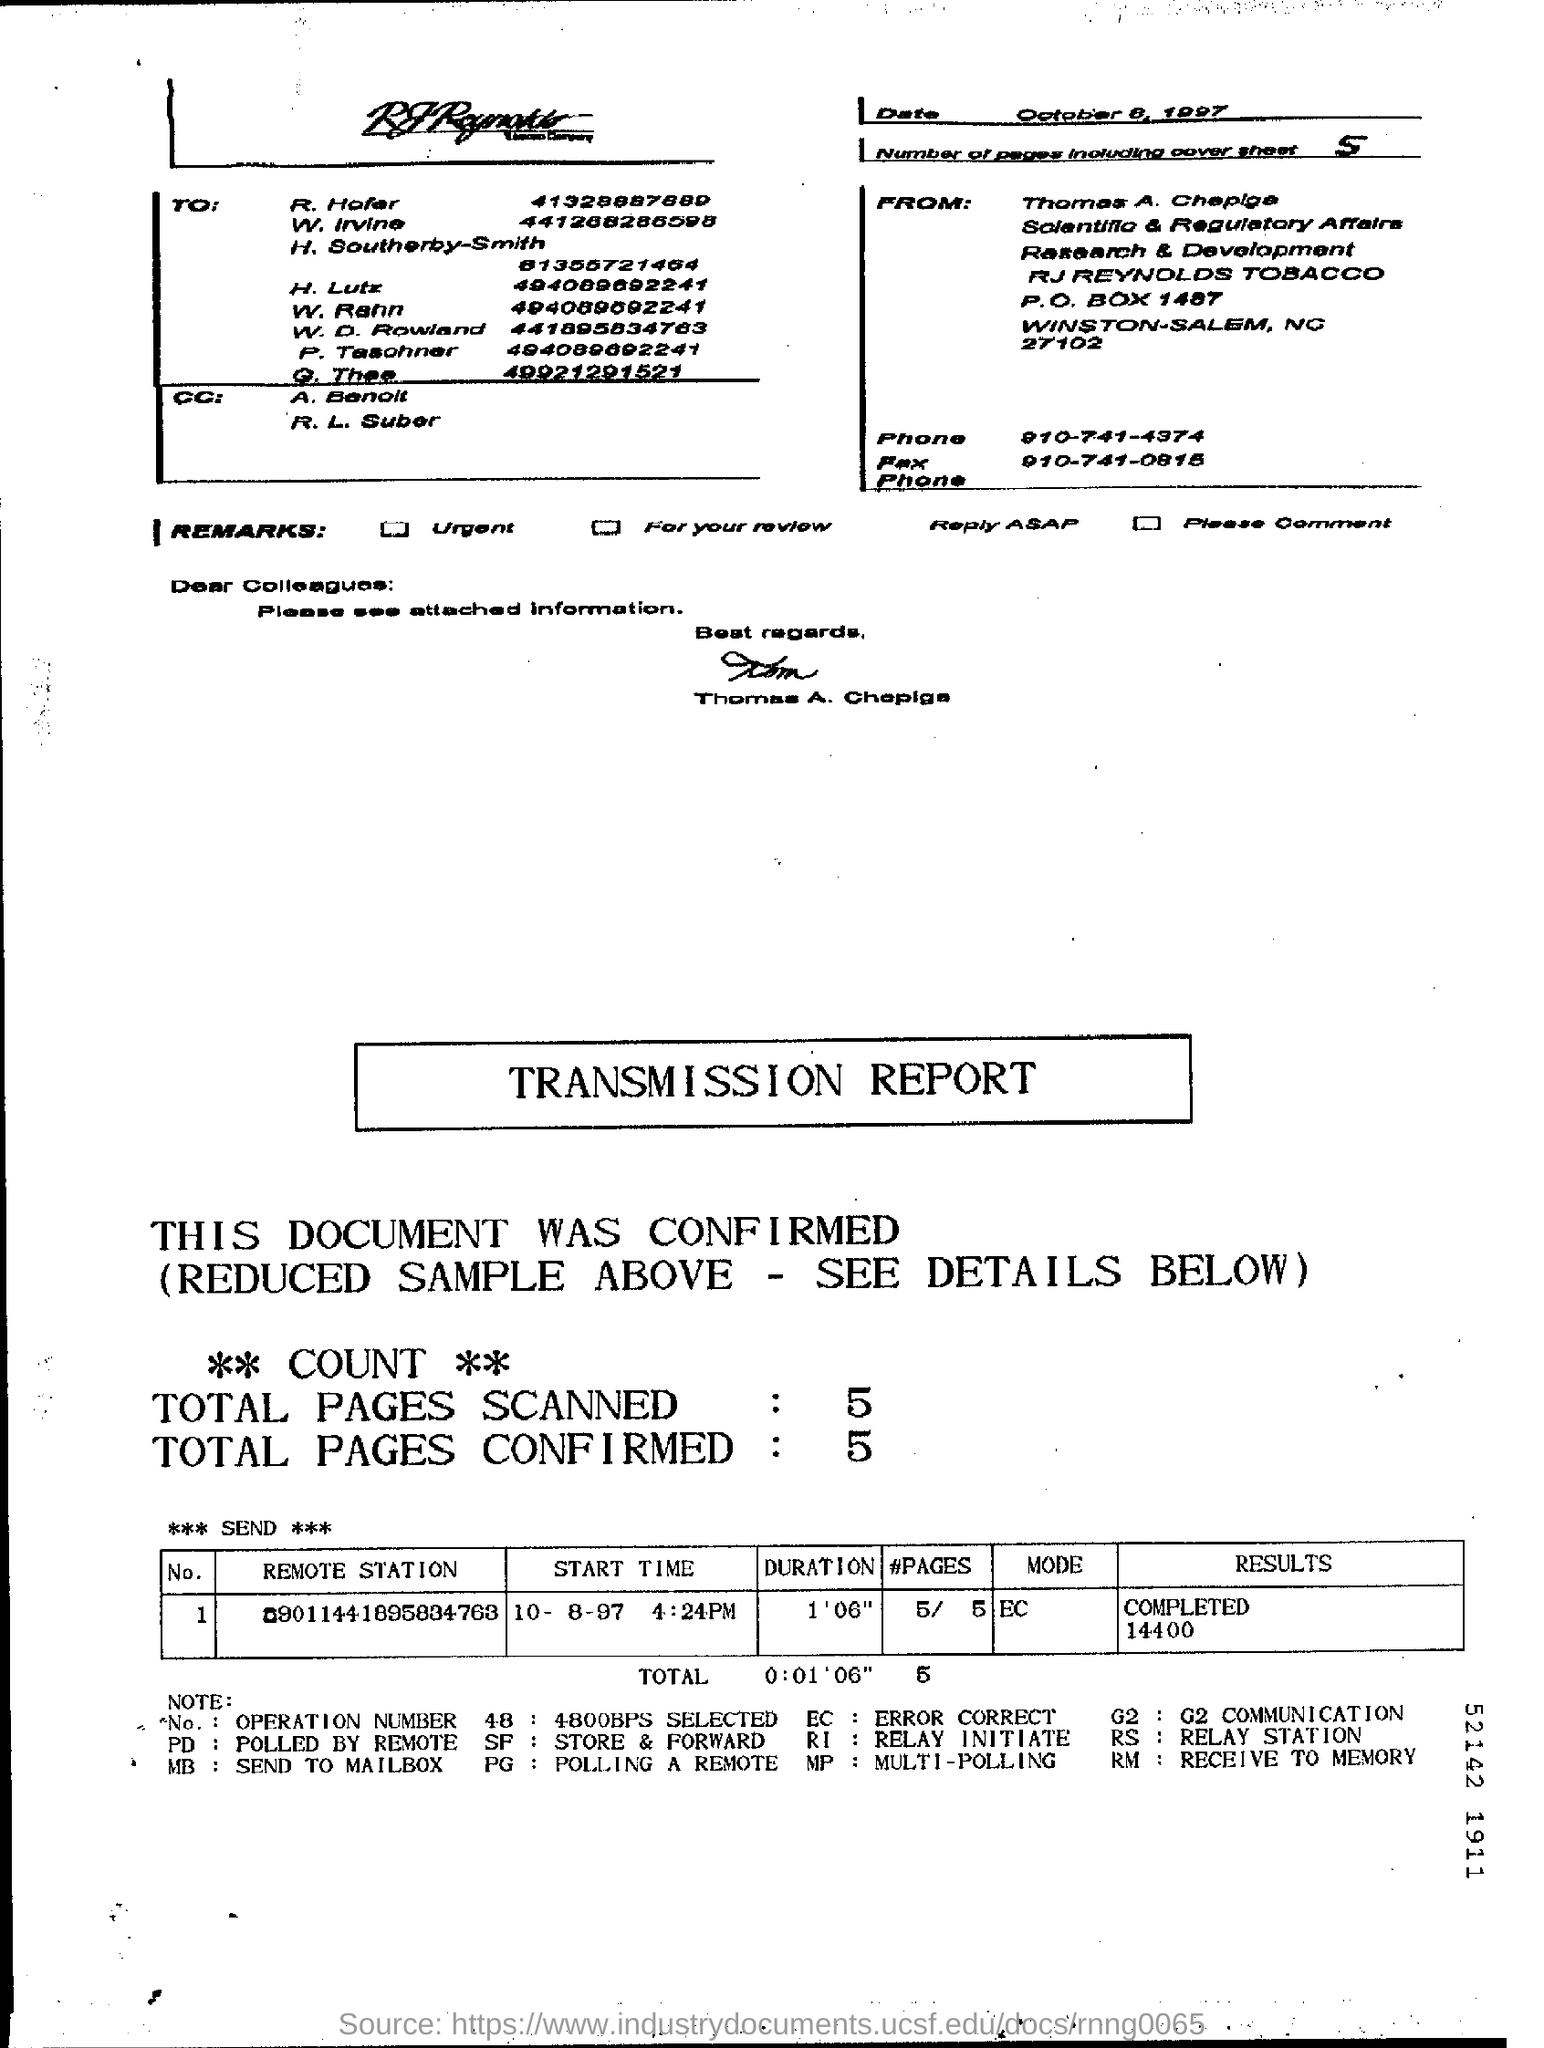Outline some significant characteristics in this image. The sender of the fax is Thomas A. Chepiga. The fax phone number of Thomas A. Chepiga is 910-741-0815. The number of pages in the fax, including the cover sheet, is five. 